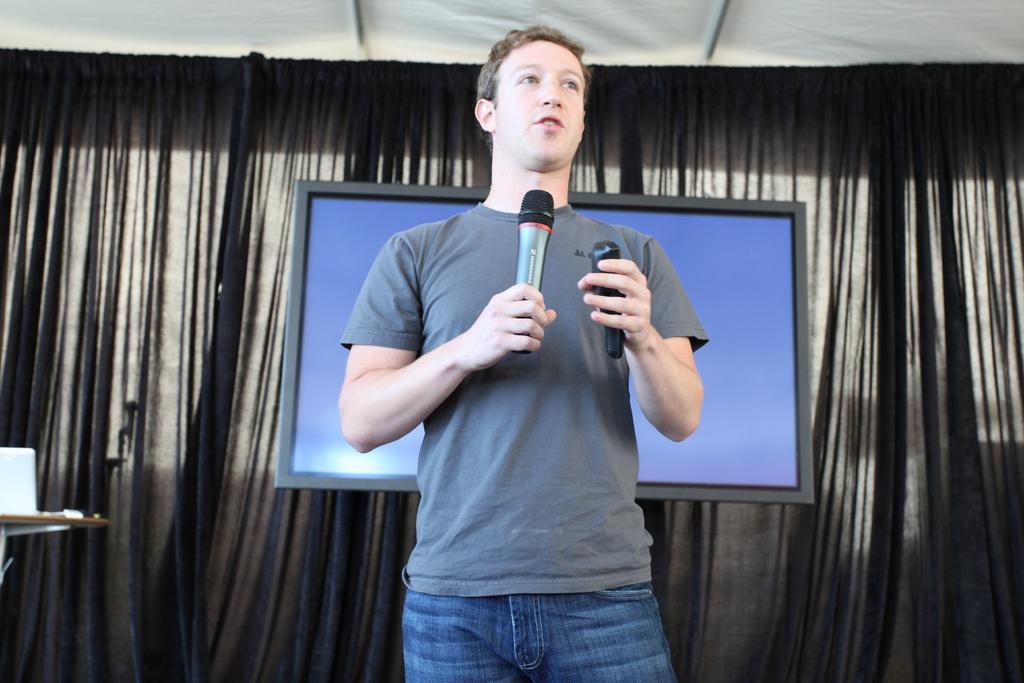Can you describe this image briefly? In this image in the center there is one man who is standing and he is holding a mike it seems that he is talking, in the background there is a curtain and television. 